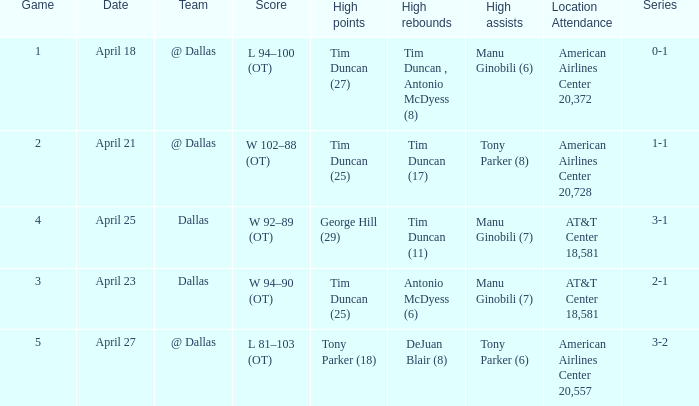When 0-1 is the series who has the highest amount of assists? Manu Ginobili (6). 